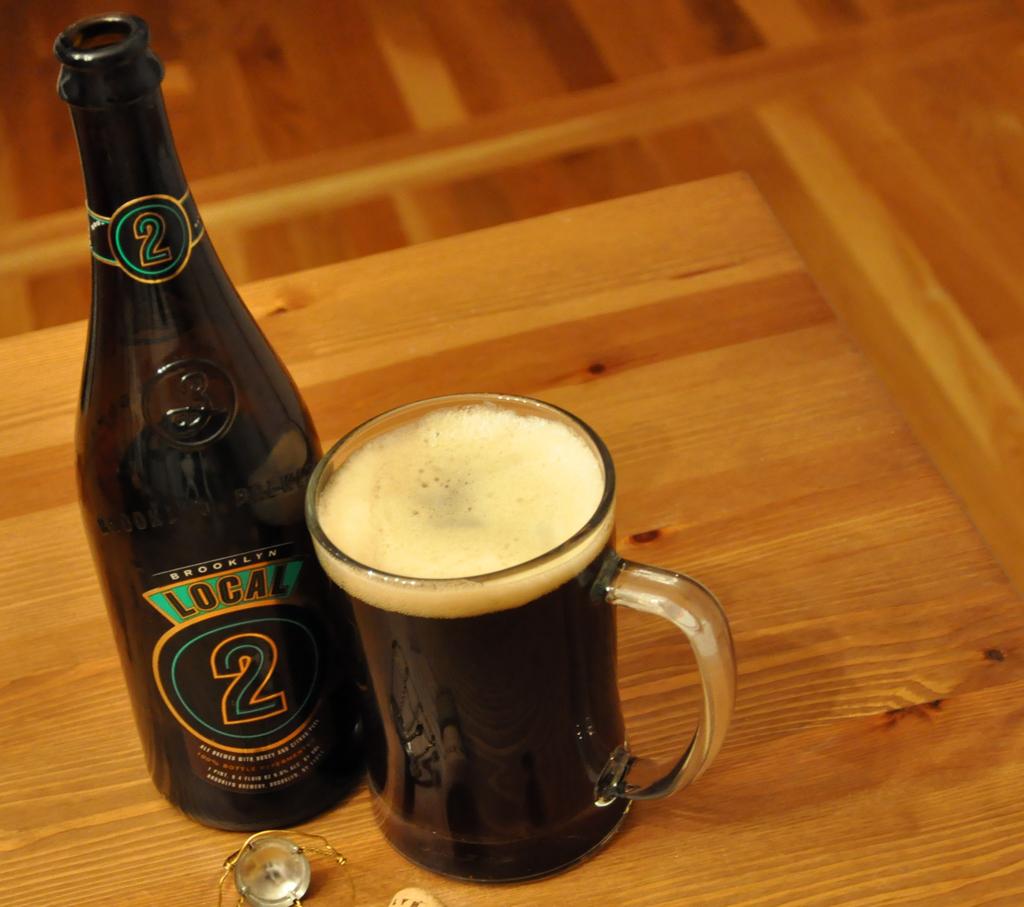What is the number on the label?
Make the answer very short. 2. 